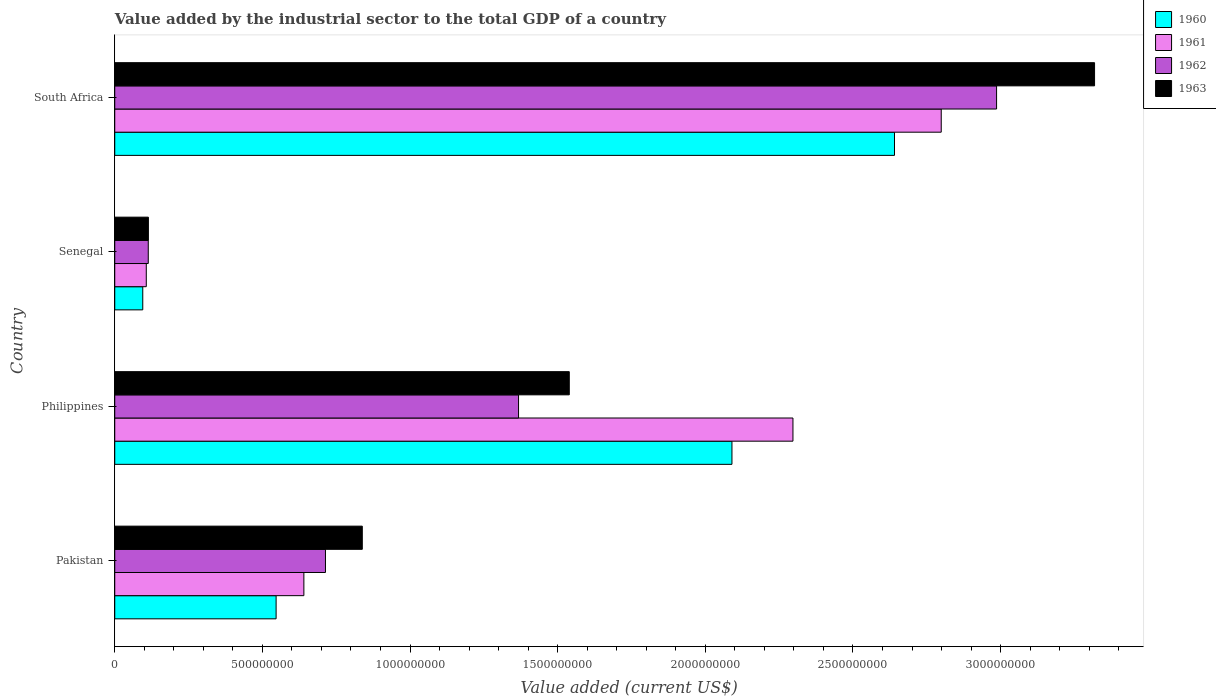How many different coloured bars are there?
Give a very brief answer. 4. How many groups of bars are there?
Give a very brief answer. 4. Are the number of bars on each tick of the Y-axis equal?
Provide a succinct answer. Yes. How many bars are there on the 2nd tick from the top?
Make the answer very short. 4. How many bars are there on the 1st tick from the bottom?
Offer a very short reply. 4. What is the value added by the industrial sector to the total GDP in 1963 in South Africa?
Keep it short and to the point. 3.32e+09. Across all countries, what is the maximum value added by the industrial sector to the total GDP in 1960?
Make the answer very short. 2.64e+09. Across all countries, what is the minimum value added by the industrial sector to the total GDP in 1962?
Your answer should be compact. 1.13e+08. In which country was the value added by the industrial sector to the total GDP in 1962 maximum?
Offer a very short reply. South Africa. In which country was the value added by the industrial sector to the total GDP in 1961 minimum?
Offer a very short reply. Senegal. What is the total value added by the industrial sector to the total GDP in 1960 in the graph?
Your answer should be compact. 5.37e+09. What is the difference between the value added by the industrial sector to the total GDP in 1963 in Philippines and that in South Africa?
Your response must be concise. -1.78e+09. What is the difference between the value added by the industrial sector to the total GDP in 1960 in Philippines and the value added by the industrial sector to the total GDP in 1963 in Pakistan?
Give a very brief answer. 1.25e+09. What is the average value added by the industrial sector to the total GDP in 1960 per country?
Provide a succinct answer. 1.34e+09. What is the difference between the value added by the industrial sector to the total GDP in 1963 and value added by the industrial sector to the total GDP in 1962 in South Africa?
Your answer should be compact. 3.32e+08. What is the ratio of the value added by the industrial sector to the total GDP in 1960 in Pakistan to that in Senegal?
Make the answer very short. 5.76. Is the value added by the industrial sector to the total GDP in 1962 in Pakistan less than that in South Africa?
Your answer should be very brief. Yes. What is the difference between the highest and the second highest value added by the industrial sector to the total GDP in 1961?
Keep it short and to the point. 5.02e+08. What is the difference between the highest and the lowest value added by the industrial sector to the total GDP in 1962?
Keep it short and to the point. 2.87e+09. Is the sum of the value added by the industrial sector to the total GDP in 1961 in Philippines and Senegal greater than the maximum value added by the industrial sector to the total GDP in 1963 across all countries?
Your answer should be very brief. No. Is it the case that in every country, the sum of the value added by the industrial sector to the total GDP in 1962 and value added by the industrial sector to the total GDP in 1960 is greater than the sum of value added by the industrial sector to the total GDP in 1961 and value added by the industrial sector to the total GDP in 1963?
Provide a short and direct response. No. Is it the case that in every country, the sum of the value added by the industrial sector to the total GDP in 1961 and value added by the industrial sector to the total GDP in 1963 is greater than the value added by the industrial sector to the total GDP in 1960?
Your answer should be very brief. Yes. How many countries are there in the graph?
Offer a terse response. 4. What is the difference between two consecutive major ticks on the X-axis?
Your answer should be compact. 5.00e+08. Does the graph contain any zero values?
Your answer should be very brief. No. Where does the legend appear in the graph?
Make the answer very short. Top right. How many legend labels are there?
Your answer should be compact. 4. What is the title of the graph?
Give a very brief answer. Value added by the industrial sector to the total GDP of a country. Does "1985" appear as one of the legend labels in the graph?
Your answer should be compact. No. What is the label or title of the X-axis?
Provide a short and direct response. Value added (current US$). What is the label or title of the Y-axis?
Your answer should be compact. Country. What is the Value added (current US$) in 1960 in Pakistan?
Offer a very short reply. 5.46e+08. What is the Value added (current US$) in 1961 in Pakistan?
Offer a very short reply. 6.40e+08. What is the Value added (current US$) in 1962 in Pakistan?
Give a very brief answer. 7.14e+08. What is the Value added (current US$) in 1963 in Pakistan?
Keep it short and to the point. 8.38e+08. What is the Value added (current US$) of 1960 in Philippines?
Provide a short and direct response. 2.09e+09. What is the Value added (current US$) of 1961 in Philippines?
Your answer should be compact. 2.30e+09. What is the Value added (current US$) of 1962 in Philippines?
Provide a short and direct response. 1.37e+09. What is the Value added (current US$) of 1963 in Philippines?
Your answer should be compact. 1.54e+09. What is the Value added (current US$) of 1960 in Senegal?
Provide a short and direct response. 9.49e+07. What is the Value added (current US$) of 1961 in Senegal?
Your response must be concise. 1.07e+08. What is the Value added (current US$) in 1962 in Senegal?
Give a very brief answer. 1.13e+08. What is the Value added (current US$) in 1963 in Senegal?
Provide a succinct answer. 1.14e+08. What is the Value added (current US$) of 1960 in South Africa?
Offer a very short reply. 2.64e+09. What is the Value added (current US$) of 1961 in South Africa?
Your answer should be very brief. 2.80e+09. What is the Value added (current US$) in 1962 in South Africa?
Make the answer very short. 2.99e+09. What is the Value added (current US$) of 1963 in South Africa?
Give a very brief answer. 3.32e+09. Across all countries, what is the maximum Value added (current US$) in 1960?
Your answer should be very brief. 2.64e+09. Across all countries, what is the maximum Value added (current US$) in 1961?
Provide a short and direct response. 2.80e+09. Across all countries, what is the maximum Value added (current US$) in 1962?
Make the answer very short. 2.99e+09. Across all countries, what is the maximum Value added (current US$) in 1963?
Give a very brief answer. 3.32e+09. Across all countries, what is the minimum Value added (current US$) of 1960?
Offer a very short reply. 9.49e+07. Across all countries, what is the minimum Value added (current US$) in 1961?
Your answer should be compact. 1.07e+08. Across all countries, what is the minimum Value added (current US$) of 1962?
Your response must be concise. 1.13e+08. Across all countries, what is the minimum Value added (current US$) of 1963?
Make the answer very short. 1.14e+08. What is the total Value added (current US$) in 1960 in the graph?
Offer a very short reply. 5.37e+09. What is the total Value added (current US$) in 1961 in the graph?
Ensure brevity in your answer.  5.84e+09. What is the total Value added (current US$) in 1962 in the graph?
Offer a very short reply. 5.18e+09. What is the total Value added (current US$) of 1963 in the graph?
Your response must be concise. 5.81e+09. What is the difference between the Value added (current US$) in 1960 in Pakistan and that in Philippines?
Your answer should be compact. -1.54e+09. What is the difference between the Value added (current US$) in 1961 in Pakistan and that in Philippines?
Ensure brevity in your answer.  -1.66e+09. What is the difference between the Value added (current US$) of 1962 in Pakistan and that in Philippines?
Provide a succinct answer. -6.54e+08. What is the difference between the Value added (current US$) in 1963 in Pakistan and that in Philippines?
Ensure brevity in your answer.  -7.01e+08. What is the difference between the Value added (current US$) in 1960 in Pakistan and that in Senegal?
Your response must be concise. 4.52e+08. What is the difference between the Value added (current US$) in 1961 in Pakistan and that in Senegal?
Provide a short and direct response. 5.34e+08. What is the difference between the Value added (current US$) of 1962 in Pakistan and that in Senegal?
Your answer should be compact. 6.00e+08. What is the difference between the Value added (current US$) in 1963 in Pakistan and that in Senegal?
Offer a terse response. 7.24e+08. What is the difference between the Value added (current US$) in 1960 in Pakistan and that in South Africa?
Your answer should be compact. -2.09e+09. What is the difference between the Value added (current US$) in 1961 in Pakistan and that in South Africa?
Your answer should be compact. -2.16e+09. What is the difference between the Value added (current US$) of 1962 in Pakistan and that in South Africa?
Your response must be concise. -2.27e+09. What is the difference between the Value added (current US$) in 1963 in Pakistan and that in South Africa?
Make the answer very short. -2.48e+09. What is the difference between the Value added (current US$) of 1960 in Philippines and that in Senegal?
Ensure brevity in your answer.  2.00e+09. What is the difference between the Value added (current US$) in 1961 in Philippines and that in Senegal?
Provide a short and direct response. 2.19e+09. What is the difference between the Value added (current US$) of 1962 in Philippines and that in Senegal?
Give a very brief answer. 1.25e+09. What is the difference between the Value added (current US$) in 1963 in Philippines and that in Senegal?
Provide a succinct answer. 1.43e+09. What is the difference between the Value added (current US$) of 1960 in Philippines and that in South Africa?
Your response must be concise. -5.50e+08. What is the difference between the Value added (current US$) of 1961 in Philippines and that in South Africa?
Provide a succinct answer. -5.02e+08. What is the difference between the Value added (current US$) in 1962 in Philippines and that in South Africa?
Make the answer very short. -1.62e+09. What is the difference between the Value added (current US$) of 1963 in Philippines and that in South Africa?
Make the answer very short. -1.78e+09. What is the difference between the Value added (current US$) of 1960 in Senegal and that in South Africa?
Offer a terse response. -2.55e+09. What is the difference between the Value added (current US$) of 1961 in Senegal and that in South Africa?
Your answer should be compact. -2.69e+09. What is the difference between the Value added (current US$) in 1962 in Senegal and that in South Africa?
Keep it short and to the point. -2.87e+09. What is the difference between the Value added (current US$) of 1963 in Senegal and that in South Africa?
Offer a very short reply. -3.20e+09. What is the difference between the Value added (current US$) in 1960 in Pakistan and the Value added (current US$) in 1961 in Philippines?
Keep it short and to the point. -1.75e+09. What is the difference between the Value added (current US$) of 1960 in Pakistan and the Value added (current US$) of 1962 in Philippines?
Offer a terse response. -8.21e+08. What is the difference between the Value added (current US$) of 1960 in Pakistan and the Value added (current US$) of 1963 in Philippines?
Keep it short and to the point. -9.93e+08. What is the difference between the Value added (current US$) of 1961 in Pakistan and the Value added (current US$) of 1962 in Philippines?
Ensure brevity in your answer.  -7.27e+08. What is the difference between the Value added (current US$) of 1961 in Pakistan and the Value added (current US$) of 1963 in Philippines?
Offer a very short reply. -8.99e+08. What is the difference between the Value added (current US$) of 1962 in Pakistan and the Value added (current US$) of 1963 in Philippines?
Offer a terse response. -8.26e+08. What is the difference between the Value added (current US$) in 1960 in Pakistan and the Value added (current US$) in 1961 in Senegal?
Offer a very short reply. 4.40e+08. What is the difference between the Value added (current US$) of 1960 in Pakistan and the Value added (current US$) of 1962 in Senegal?
Your answer should be very brief. 4.33e+08. What is the difference between the Value added (current US$) in 1960 in Pakistan and the Value added (current US$) in 1963 in Senegal?
Make the answer very short. 4.32e+08. What is the difference between the Value added (current US$) in 1961 in Pakistan and the Value added (current US$) in 1962 in Senegal?
Keep it short and to the point. 5.27e+08. What is the difference between the Value added (current US$) in 1961 in Pakistan and the Value added (current US$) in 1963 in Senegal?
Your answer should be compact. 5.27e+08. What is the difference between the Value added (current US$) in 1962 in Pakistan and the Value added (current US$) in 1963 in Senegal?
Ensure brevity in your answer.  6.00e+08. What is the difference between the Value added (current US$) of 1960 in Pakistan and the Value added (current US$) of 1961 in South Africa?
Ensure brevity in your answer.  -2.25e+09. What is the difference between the Value added (current US$) of 1960 in Pakistan and the Value added (current US$) of 1962 in South Africa?
Provide a short and direct response. -2.44e+09. What is the difference between the Value added (current US$) in 1960 in Pakistan and the Value added (current US$) in 1963 in South Africa?
Your answer should be compact. -2.77e+09. What is the difference between the Value added (current US$) of 1961 in Pakistan and the Value added (current US$) of 1962 in South Africa?
Provide a succinct answer. -2.35e+09. What is the difference between the Value added (current US$) of 1961 in Pakistan and the Value added (current US$) of 1963 in South Africa?
Make the answer very short. -2.68e+09. What is the difference between the Value added (current US$) of 1962 in Pakistan and the Value added (current US$) of 1963 in South Africa?
Keep it short and to the point. -2.60e+09. What is the difference between the Value added (current US$) of 1960 in Philippines and the Value added (current US$) of 1961 in Senegal?
Your answer should be compact. 1.98e+09. What is the difference between the Value added (current US$) in 1960 in Philippines and the Value added (current US$) in 1962 in Senegal?
Give a very brief answer. 1.98e+09. What is the difference between the Value added (current US$) of 1960 in Philippines and the Value added (current US$) of 1963 in Senegal?
Provide a succinct answer. 1.98e+09. What is the difference between the Value added (current US$) in 1961 in Philippines and the Value added (current US$) in 1962 in Senegal?
Keep it short and to the point. 2.18e+09. What is the difference between the Value added (current US$) of 1961 in Philippines and the Value added (current US$) of 1963 in Senegal?
Offer a terse response. 2.18e+09. What is the difference between the Value added (current US$) of 1962 in Philippines and the Value added (current US$) of 1963 in Senegal?
Make the answer very short. 1.25e+09. What is the difference between the Value added (current US$) in 1960 in Philippines and the Value added (current US$) in 1961 in South Africa?
Keep it short and to the point. -7.09e+08. What is the difference between the Value added (current US$) of 1960 in Philippines and the Value added (current US$) of 1962 in South Africa?
Offer a very short reply. -8.96e+08. What is the difference between the Value added (current US$) of 1960 in Philippines and the Value added (current US$) of 1963 in South Africa?
Offer a terse response. -1.23e+09. What is the difference between the Value added (current US$) of 1961 in Philippines and the Value added (current US$) of 1962 in South Africa?
Make the answer very short. -6.90e+08. What is the difference between the Value added (current US$) of 1961 in Philippines and the Value added (current US$) of 1963 in South Africa?
Your answer should be very brief. -1.02e+09. What is the difference between the Value added (current US$) in 1962 in Philippines and the Value added (current US$) in 1963 in South Africa?
Your response must be concise. -1.95e+09. What is the difference between the Value added (current US$) in 1960 in Senegal and the Value added (current US$) in 1961 in South Africa?
Make the answer very short. -2.70e+09. What is the difference between the Value added (current US$) in 1960 in Senegal and the Value added (current US$) in 1962 in South Africa?
Keep it short and to the point. -2.89e+09. What is the difference between the Value added (current US$) of 1960 in Senegal and the Value added (current US$) of 1963 in South Africa?
Your answer should be compact. -3.22e+09. What is the difference between the Value added (current US$) of 1961 in Senegal and the Value added (current US$) of 1962 in South Africa?
Offer a very short reply. -2.88e+09. What is the difference between the Value added (current US$) of 1961 in Senegal and the Value added (current US$) of 1963 in South Africa?
Provide a short and direct response. -3.21e+09. What is the difference between the Value added (current US$) of 1962 in Senegal and the Value added (current US$) of 1963 in South Africa?
Provide a short and direct response. -3.20e+09. What is the average Value added (current US$) in 1960 per country?
Ensure brevity in your answer.  1.34e+09. What is the average Value added (current US$) of 1961 per country?
Your response must be concise. 1.46e+09. What is the average Value added (current US$) in 1962 per country?
Ensure brevity in your answer.  1.30e+09. What is the average Value added (current US$) of 1963 per country?
Your answer should be compact. 1.45e+09. What is the difference between the Value added (current US$) in 1960 and Value added (current US$) in 1961 in Pakistan?
Your answer should be very brief. -9.41e+07. What is the difference between the Value added (current US$) of 1960 and Value added (current US$) of 1962 in Pakistan?
Make the answer very short. -1.67e+08. What is the difference between the Value added (current US$) in 1960 and Value added (current US$) in 1963 in Pakistan?
Your response must be concise. -2.92e+08. What is the difference between the Value added (current US$) of 1961 and Value added (current US$) of 1962 in Pakistan?
Provide a short and direct response. -7.31e+07. What is the difference between the Value added (current US$) in 1961 and Value added (current US$) in 1963 in Pakistan?
Offer a very short reply. -1.98e+08. What is the difference between the Value added (current US$) of 1962 and Value added (current US$) of 1963 in Pakistan?
Offer a terse response. -1.25e+08. What is the difference between the Value added (current US$) of 1960 and Value added (current US$) of 1961 in Philippines?
Provide a succinct answer. -2.07e+08. What is the difference between the Value added (current US$) in 1960 and Value added (current US$) in 1962 in Philippines?
Provide a succinct answer. 7.23e+08. What is the difference between the Value added (current US$) in 1960 and Value added (current US$) in 1963 in Philippines?
Provide a short and direct response. 5.51e+08. What is the difference between the Value added (current US$) in 1961 and Value added (current US$) in 1962 in Philippines?
Provide a succinct answer. 9.29e+08. What is the difference between the Value added (current US$) in 1961 and Value added (current US$) in 1963 in Philippines?
Your response must be concise. 7.57e+08. What is the difference between the Value added (current US$) in 1962 and Value added (current US$) in 1963 in Philippines?
Keep it short and to the point. -1.72e+08. What is the difference between the Value added (current US$) in 1960 and Value added (current US$) in 1961 in Senegal?
Provide a short and direct response. -1.19e+07. What is the difference between the Value added (current US$) in 1960 and Value added (current US$) in 1962 in Senegal?
Your answer should be very brief. -1.86e+07. What is the difference between the Value added (current US$) in 1960 and Value added (current US$) in 1963 in Senegal?
Provide a succinct answer. -1.91e+07. What is the difference between the Value added (current US$) in 1961 and Value added (current US$) in 1962 in Senegal?
Offer a very short reply. -6.73e+06. What is the difference between the Value added (current US$) of 1961 and Value added (current US$) of 1963 in Senegal?
Make the answer very short. -7.17e+06. What is the difference between the Value added (current US$) of 1962 and Value added (current US$) of 1963 in Senegal?
Give a very brief answer. -4.40e+05. What is the difference between the Value added (current US$) of 1960 and Value added (current US$) of 1961 in South Africa?
Keep it short and to the point. -1.58e+08. What is the difference between the Value added (current US$) of 1960 and Value added (current US$) of 1962 in South Africa?
Give a very brief answer. -3.46e+08. What is the difference between the Value added (current US$) of 1960 and Value added (current US$) of 1963 in South Africa?
Provide a short and direct response. -6.78e+08. What is the difference between the Value added (current US$) in 1961 and Value added (current US$) in 1962 in South Africa?
Your response must be concise. -1.87e+08. What is the difference between the Value added (current US$) in 1961 and Value added (current US$) in 1963 in South Africa?
Your answer should be compact. -5.19e+08. What is the difference between the Value added (current US$) in 1962 and Value added (current US$) in 1963 in South Africa?
Offer a terse response. -3.32e+08. What is the ratio of the Value added (current US$) of 1960 in Pakistan to that in Philippines?
Your answer should be compact. 0.26. What is the ratio of the Value added (current US$) in 1961 in Pakistan to that in Philippines?
Provide a short and direct response. 0.28. What is the ratio of the Value added (current US$) of 1962 in Pakistan to that in Philippines?
Offer a terse response. 0.52. What is the ratio of the Value added (current US$) of 1963 in Pakistan to that in Philippines?
Offer a very short reply. 0.54. What is the ratio of the Value added (current US$) of 1960 in Pakistan to that in Senegal?
Make the answer very short. 5.76. What is the ratio of the Value added (current US$) in 1961 in Pakistan to that in Senegal?
Offer a very short reply. 6. What is the ratio of the Value added (current US$) in 1962 in Pakistan to that in Senegal?
Make the answer very short. 6.29. What is the ratio of the Value added (current US$) in 1963 in Pakistan to that in Senegal?
Keep it short and to the point. 7.36. What is the ratio of the Value added (current US$) in 1960 in Pakistan to that in South Africa?
Your answer should be compact. 0.21. What is the ratio of the Value added (current US$) of 1961 in Pakistan to that in South Africa?
Make the answer very short. 0.23. What is the ratio of the Value added (current US$) of 1962 in Pakistan to that in South Africa?
Offer a terse response. 0.24. What is the ratio of the Value added (current US$) of 1963 in Pakistan to that in South Africa?
Provide a short and direct response. 0.25. What is the ratio of the Value added (current US$) in 1960 in Philippines to that in Senegal?
Keep it short and to the point. 22.03. What is the ratio of the Value added (current US$) of 1961 in Philippines to that in Senegal?
Offer a very short reply. 21.51. What is the ratio of the Value added (current US$) in 1962 in Philippines to that in Senegal?
Keep it short and to the point. 12.05. What is the ratio of the Value added (current US$) in 1963 in Philippines to that in Senegal?
Give a very brief answer. 13.51. What is the ratio of the Value added (current US$) of 1960 in Philippines to that in South Africa?
Your answer should be compact. 0.79. What is the ratio of the Value added (current US$) in 1961 in Philippines to that in South Africa?
Your answer should be compact. 0.82. What is the ratio of the Value added (current US$) in 1962 in Philippines to that in South Africa?
Provide a short and direct response. 0.46. What is the ratio of the Value added (current US$) of 1963 in Philippines to that in South Africa?
Make the answer very short. 0.46. What is the ratio of the Value added (current US$) of 1960 in Senegal to that in South Africa?
Provide a succinct answer. 0.04. What is the ratio of the Value added (current US$) in 1961 in Senegal to that in South Africa?
Provide a short and direct response. 0.04. What is the ratio of the Value added (current US$) of 1962 in Senegal to that in South Africa?
Offer a very short reply. 0.04. What is the ratio of the Value added (current US$) in 1963 in Senegal to that in South Africa?
Give a very brief answer. 0.03. What is the difference between the highest and the second highest Value added (current US$) of 1960?
Your response must be concise. 5.50e+08. What is the difference between the highest and the second highest Value added (current US$) of 1961?
Give a very brief answer. 5.02e+08. What is the difference between the highest and the second highest Value added (current US$) of 1962?
Offer a very short reply. 1.62e+09. What is the difference between the highest and the second highest Value added (current US$) in 1963?
Offer a terse response. 1.78e+09. What is the difference between the highest and the lowest Value added (current US$) in 1960?
Ensure brevity in your answer.  2.55e+09. What is the difference between the highest and the lowest Value added (current US$) in 1961?
Your answer should be compact. 2.69e+09. What is the difference between the highest and the lowest Value added (current US$) of 1962?
Your response must be concise. 2.87e+09. What is the difference between the highest and the lowest Value added (current US$) of 1963?
Your answer should be very brief. 3.20e+09. 